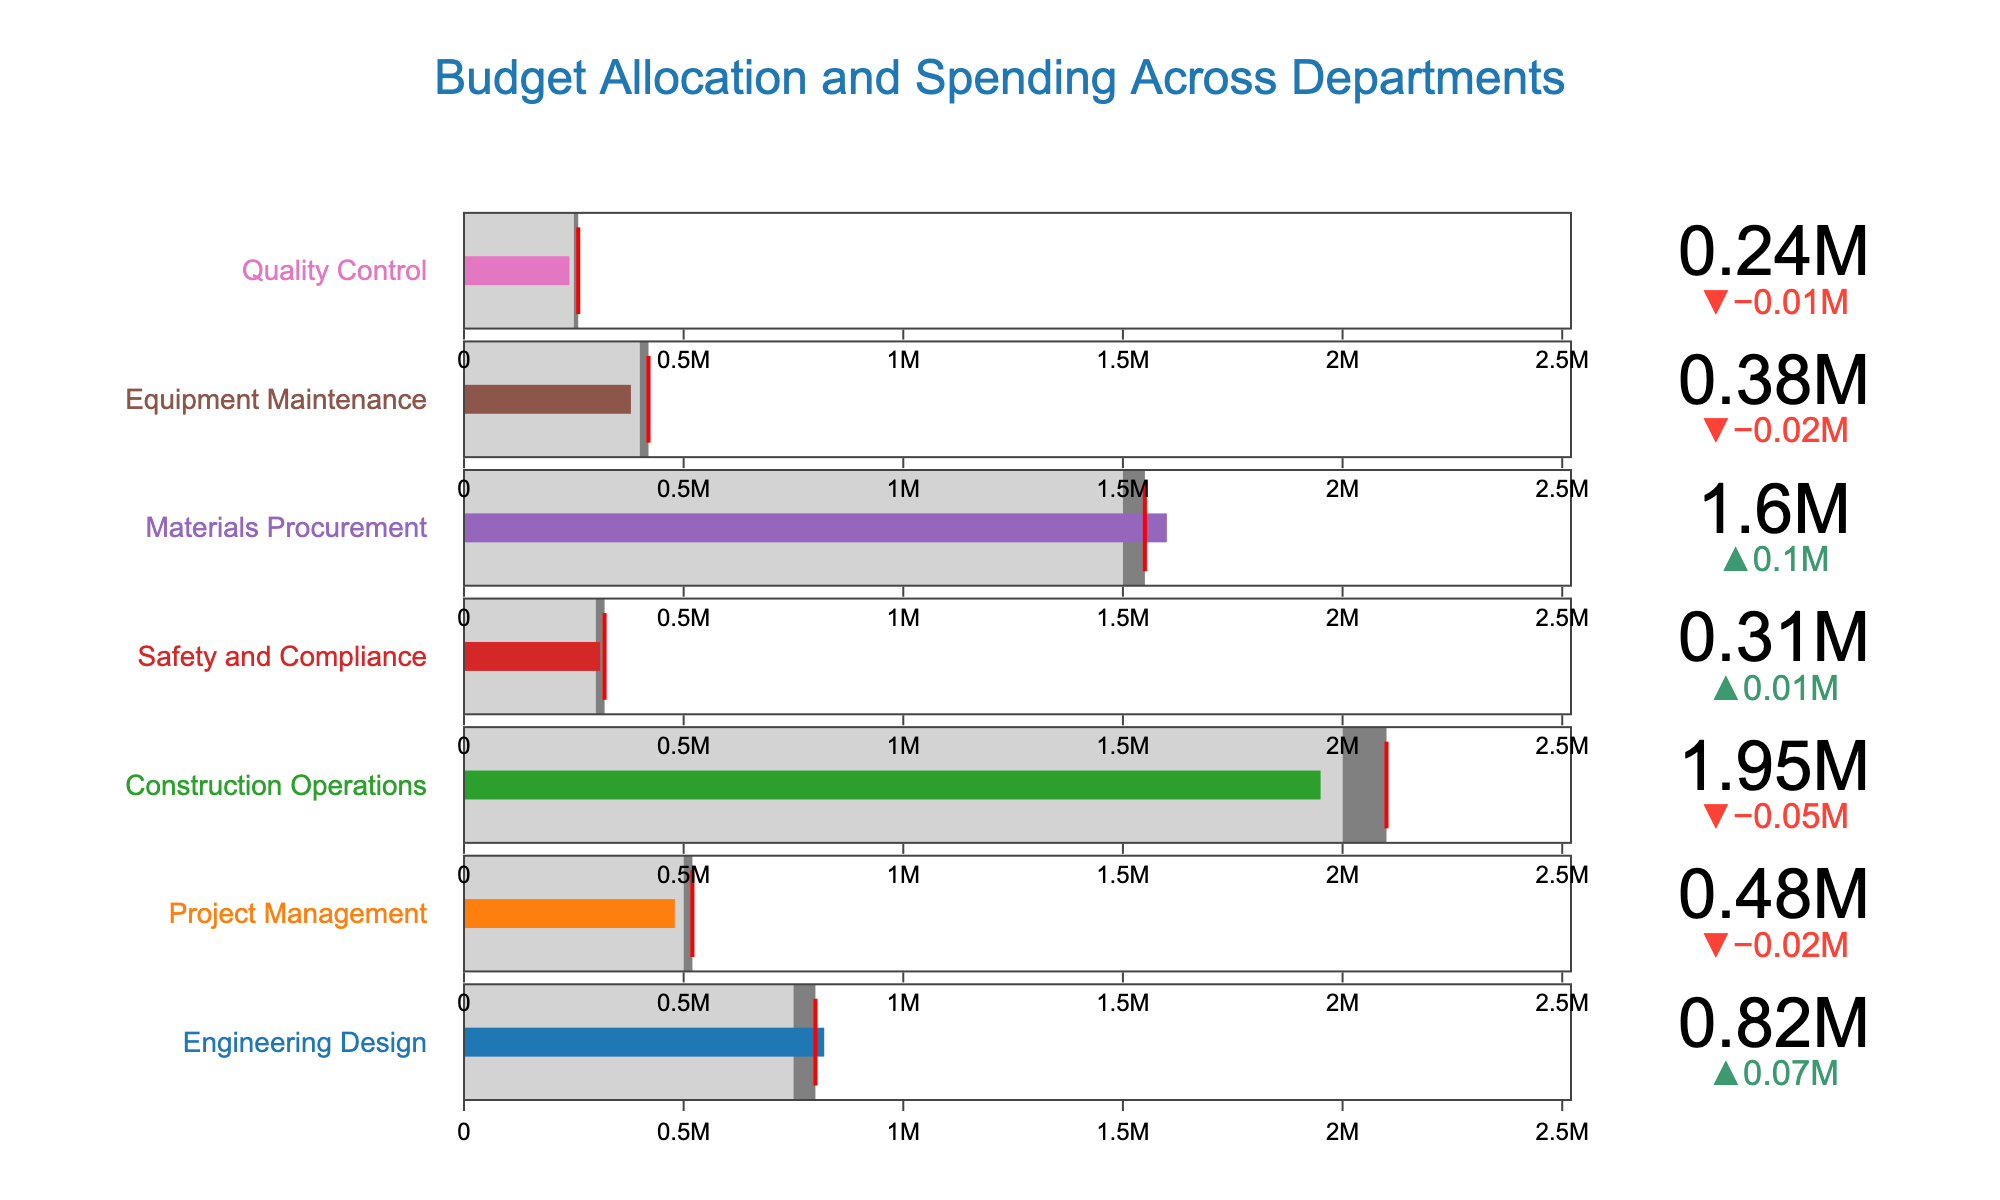Which department had the highest actual spending? The department with the highest actual spending can be identified directly by looking at the bullet charts and comparing the values. The "Construction Operations" department has the highest actual spending of 1,950,000.
Answer: Construction Operations What is the difference between the actual spending and the planned budget for the Engineering Design department? To find the difference between the actual spending and the planned budget for the Engineering Design department, subtract the planned budget from the actual spending: 820,000 - 750,000 = 70,000.
Answer: 70,000 Which departments met or exceeded their target spending? By looking at the gauge indicators with red thresholds (targets) relative to the actual spending, the departments that met or exceeded their targets are those where the actual spending reached or surpassed the target. These are "Safety and Compliance" and "Materials Procurement".
Answer: Safety and Compliance, Materials Procurement Which department had the greatest underspend compared to its planned budget? By reviewing the delta indicators (differences between actual spending and planned budget), we can see that the department with the greatest underspend (where the delta is most negative) is "Equipment Maintenance" with an actual spending of 380,000 compared to a planned budget of 400,000. The difference is 400,000 - 380,000 = 20,000.
Answer: Equipment Maintenance How much more did the Materials Procurement department spend compared to its target? To find how much more was spent by the Materials Procurement department beyond its target, subtract the target from the actual spending: 1,600,000 - 1,550,000 = 50,000.
Answer: 50,000 Is the planned budget for Project Management lower than the actual spending for Equipment Maintenance? By comparing the planned budget value for Project Management (500,000) with the actual spending for Equipment Maintenance (380,000), we can see that the planned budget for Project Management is higher.
Answer: No What is the average actual spending across all departments? Add up all the actual spending values and divide by the number of departments: (820,000 + 480,000 + 1,950,000 + 310,000 + 1,600,000 + 380,000 + 240,000) / 7 = 5,780,000 / 7 = 825,714 approximately.
Answer: 825,714 Which department had the largest percentage overspend relative to its planned budget? To determine this, calculate the percentage overspend for each department (Actual Spending / Planned Budget - 1) * 100 and compare them. For "Engineering Design": (820,000 / 750,000 - 1) * 100 ≈ 9.33%. For "Project Management": (480,000 / 500,000 - 1) * 100 ≈ -4%. For "Construction Operations": (1,950,000 / 2,000,000 - 1) * 100 ≈ -2.5%. For "Safety and Compliance" (310,000 / 300,000 - 1) * 100 ≈ 3.33%. For "Materials Procurement": (1,600,000 / 1,500,000 - 1) * 100 ≈ 6.67%. For "Equipment Maintenance": (380,000 / 400,000 - 1) * 100 ≈ -5%. For "Quality Control": (240,000 / 250,000 - 1) * 100 ≈ -4%. The highest is 9.33% for Engineering Design.
Answer: Engineering Design 